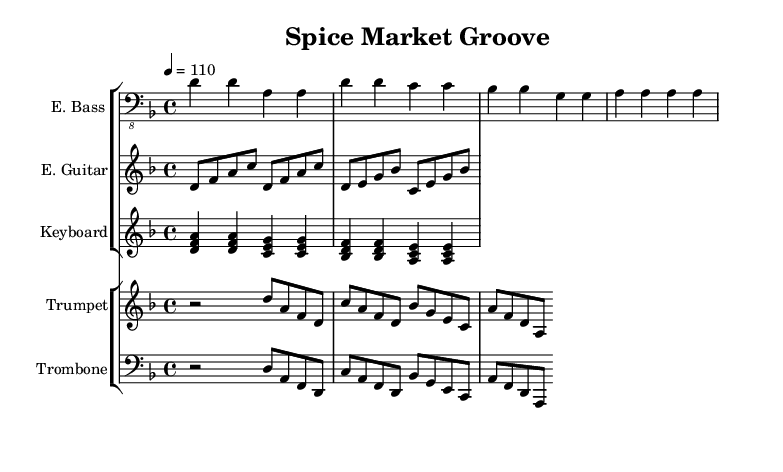What is the key signature of this music? The key signature is indicated at the beginning of the score, which shows two flats (B♭ and E♭), indicating that the key is D minor.
Answer: D minor What is the time signature of this music? The time signature is located near the beginning of the score, showing a '4/4' time signature, which means there are four beats per measure and a quarter note gets one beat.
Answer: 4/4 What is the tempo marking for this piece? The tempo marking is found above the staff, indicating that the piece should be played at a speed of 110 beats per minute, shown as "4 = 110."
Answer: 110 How many measures are present in the electric bass part? Counting the measures in the electric bass part, we find that there are four measures total in the provided section.
Answer: 4 Which instrument is notated in the treble clef? The music for the trumpet is notated in the treble clef, which is used for higher-pitched instruments, unlike the bass clef used for others.
Answer: Trumpet What are the root notes of the chords in the keyboard part? The keyboard part consists of several chords, and identifying the root notes of the first few chords leads to the notes D, C, and B♭ for each corresponding measure.
Answer: D, C, B♭ Which instruments play the melody? Reviewing the score, the trumpet and trombone parts play melodic lines, whereas other instruments typically provide harmonic support or rhythm.
Answer: Trumpet, Trombone 